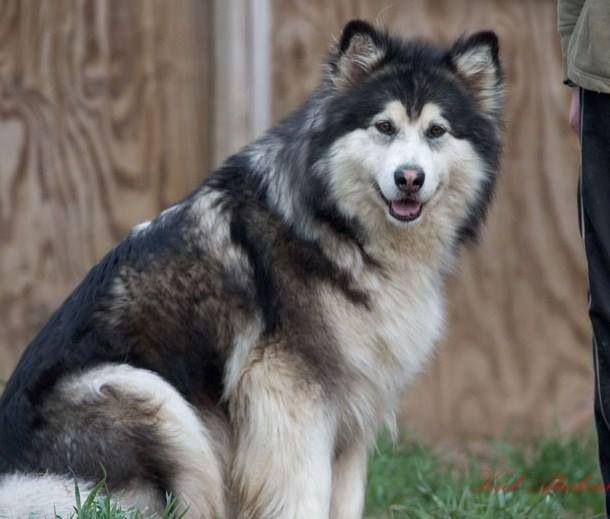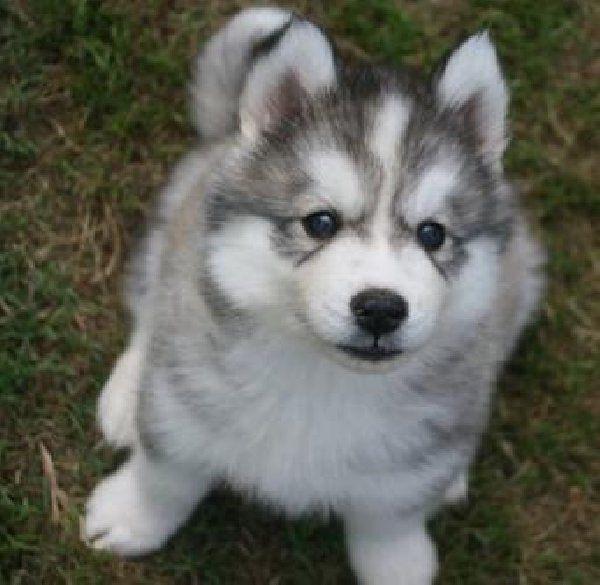The first image is the image on the left, the second image is the image on the right. Analyze the images presented: Is the assertion "One image shows a gray-and-white husky puppy sitting upright, and the other image shows a darker adult husky with its mouth open." valid? Answer yes or no. Yes. The first image is the image on the left, the second image is the image on the right. For the images displayed, is the sentence "There is a puppy and an adult dog" factually correct? Answer yes or no. Yes. 